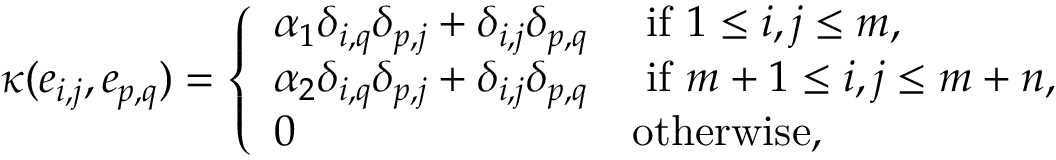Convert formula to latex. <formula><loc_0><loc_0><loc_500><loc_500>\kappa ( e _ { i , j } , e _ { p , q } ) = \left \{ \begin{array} { l l } { \alpha _ { 1 } \delta _ { i , q } \delta _ { p , j } + \delta _ { i , j } \delta _ { p , q } } & { i f 1 \leq i , j \leq m , } \\ { \alpha _ { 2 } \delta _ { i , q } \delta _ { p , j } + \delta _ { i , j } \delta _ { p , q } } & { i f m + 1 \leq i , j \leq m + n , } \\ { 0 } & { o t h e r w i s e , } \end{array}</formula> 